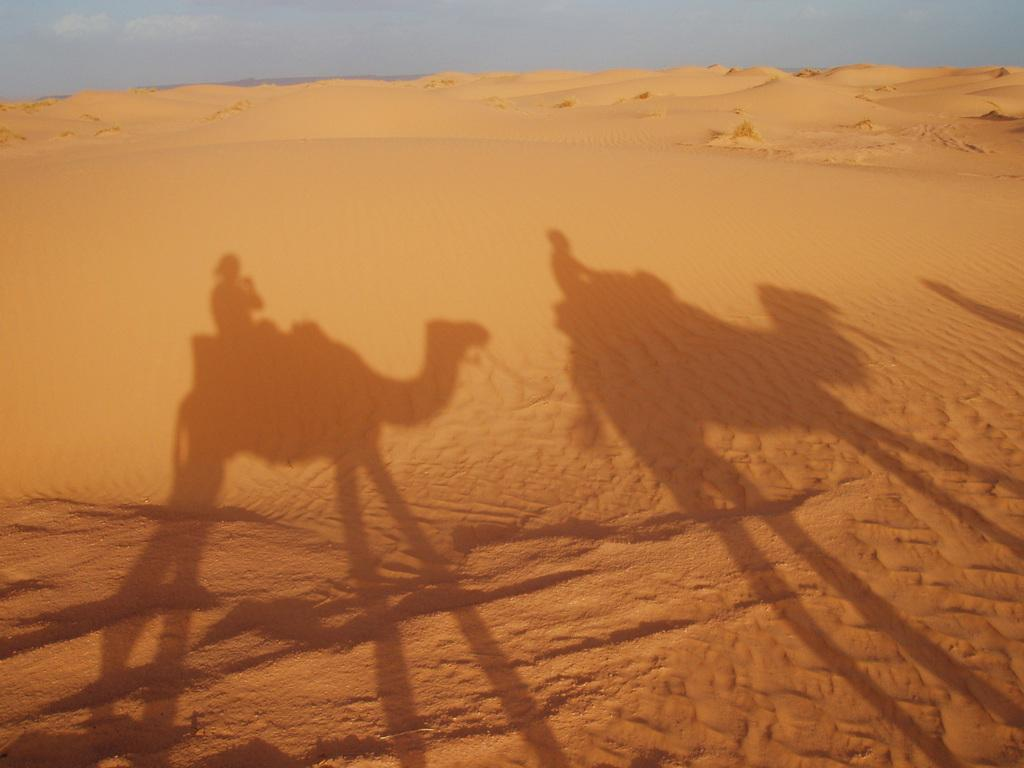What is the main element that makes up the image? The image primarily consists of sand. What can be seen in the sand? There are shadows of two camels on the sand. What are the camels doing in the image? People are sitting on the camels. What is the condition of the sky in the image? The sky is visible and appears cloudy. How many dimes can be seen buried in the sand in the image? There are no dimes visible in the image; it primarily consists of sand and shadows of camels. What type of wool is being used to create the camels' fur in the image? There is no wool present in the image, as the camels are depicted through shadows. 